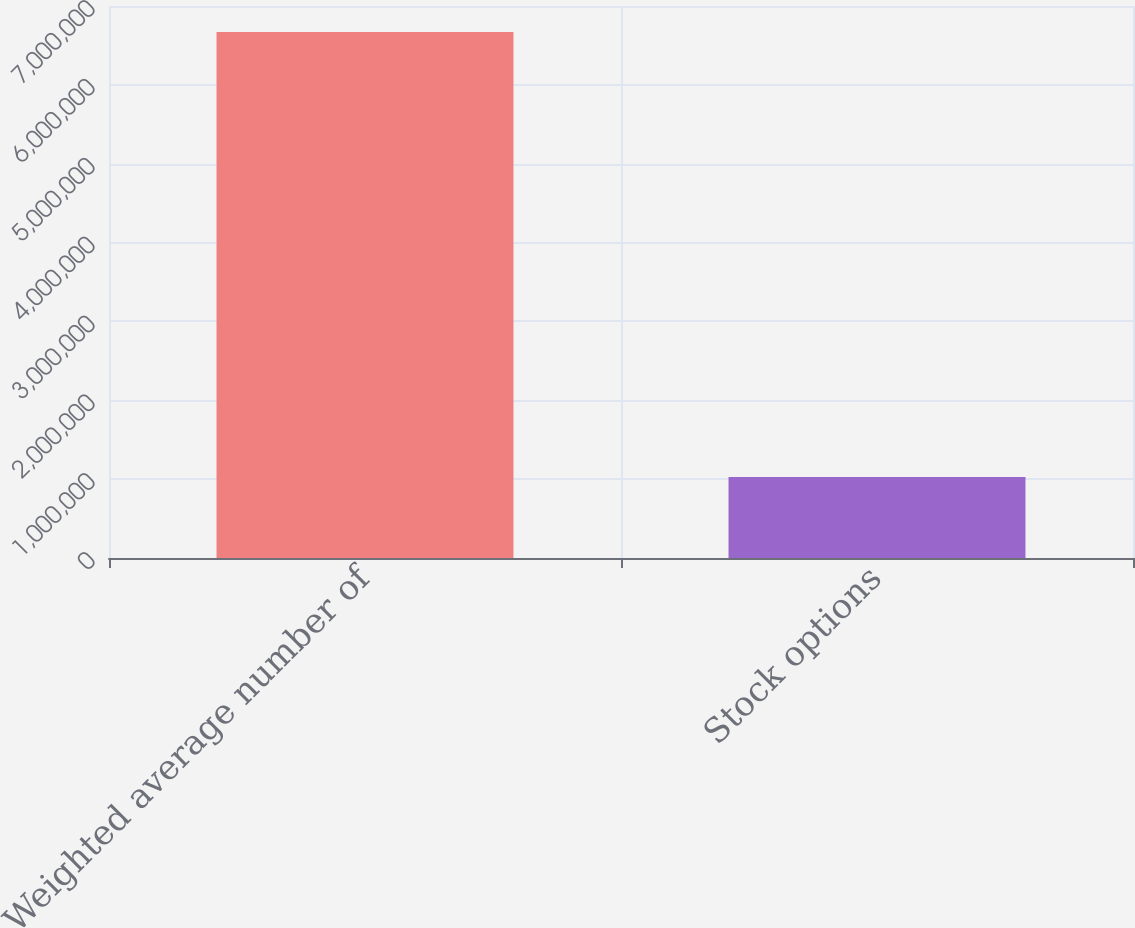Convert chart to OTSL. <chart><loc_0><loc_0><loc_500><loc_500><bar_chart><fcel>Weighted average number of<fcel>Stock options<nl><fcel>6.67157e+06<fcel>1.0275e+06<nl></chart> 